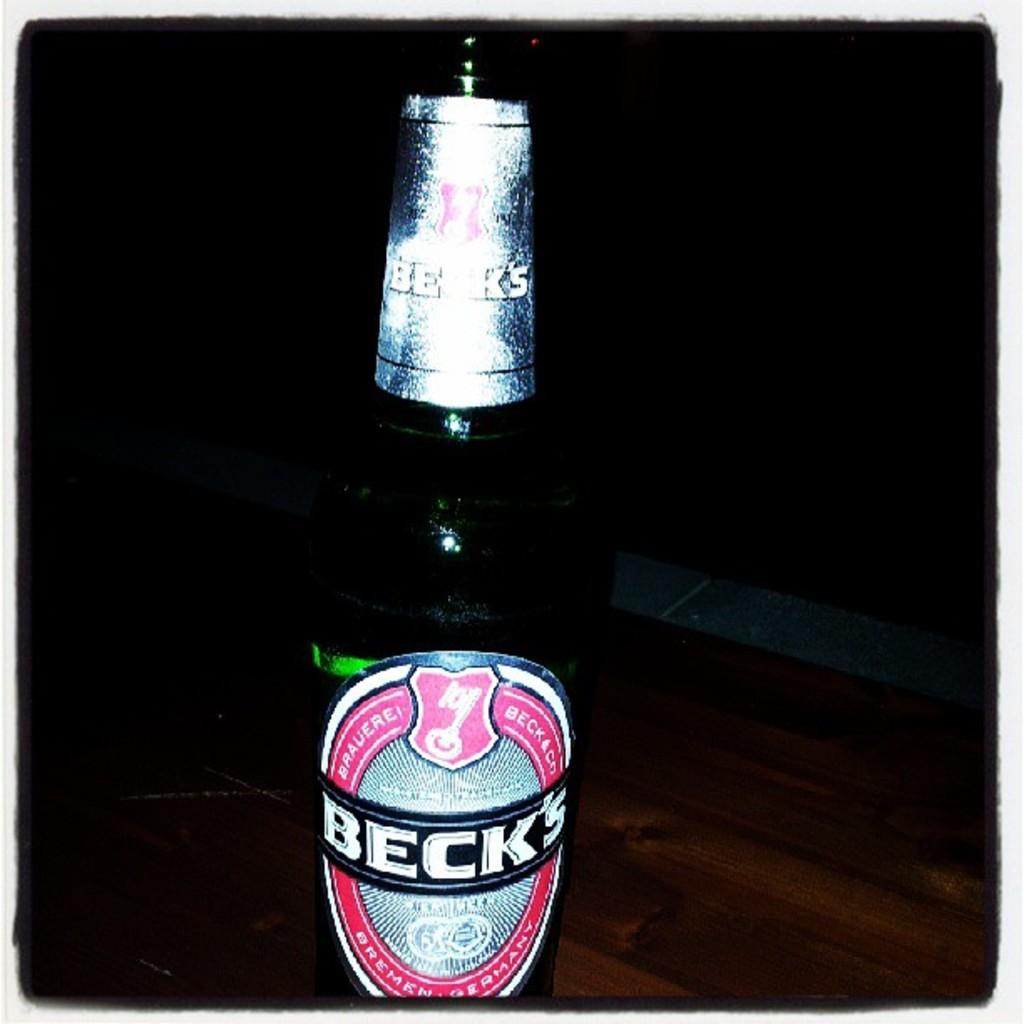<image>
Relay a brief, clear account of the picture shown. A bottle of Beck's beer stands on a wooden table. 